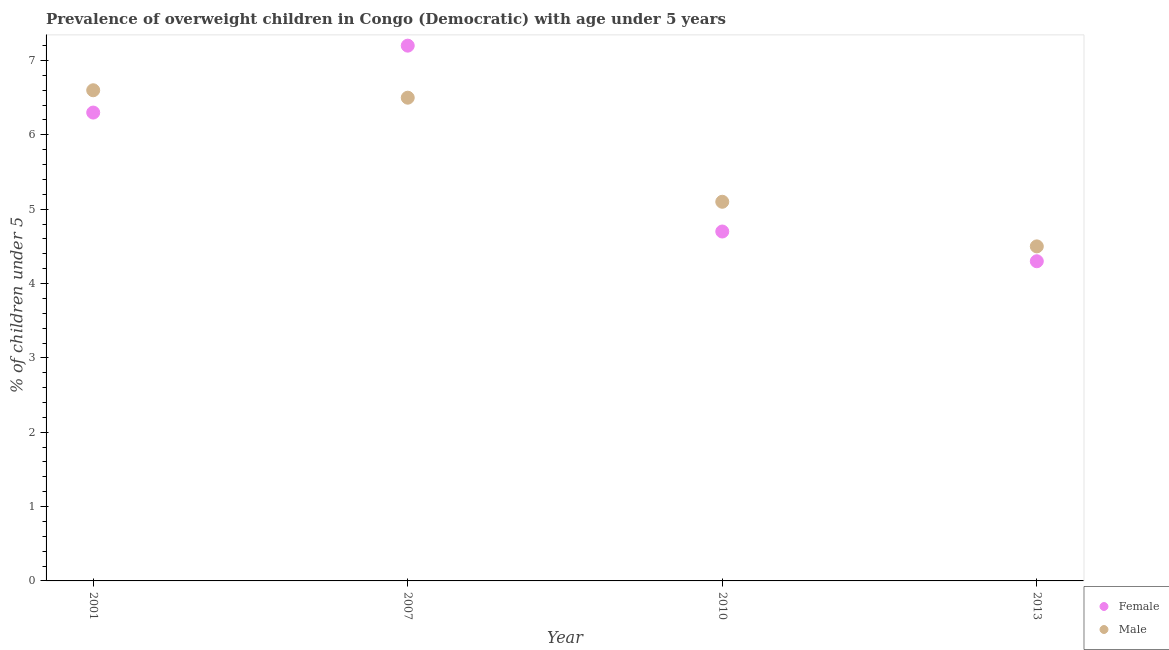How many different coloured dotlines are there?
Offer a terse response. 2. What is the percentage of obese male children in 2010?
Keep it short and to the point. 5.1. Across all years, what is the maximum percentage of obese male children?
Provide a short and direct response. 6.6. Across all years, what is the minimum percentage of obese female children?
Make the answer very short. 4.3. What is the total percentage of obese male children in the graph?
Offer a very short reply. 22.7. What is the difference between the percentage of obese female children in 2007 and that in 2010?
Provide a succinct answer. 2.5. What is the difference between the percentage of obese female children in 2001 and the percentage of obese male children in 2013?
Keep it short and to the point. 1.8. What is the average percentage of obese male children per year?
Provide a short and direct response. 5.67. In the year 2010, what is the difference between the percentage of obese female children and percentage of obese male children?
Ensure brevity in your answer.  -0.4. What is the ratio of the percentage of obese male children in 2001 to that in 2013?
Your response must be concise. 1.47. Is the difference between the percentage of obese female children in 2001 and 2013 greater than the difference between the percentage of obese male children in 2001 and 2013?
Keep it short and to the point. No. What is the difference between the highest and the second highest percentage of obese male children?
Your response must be concise. 0.1. What is the difference between the highest and the lowest percentage of obese female children?
Provide a short and direct response. 2.9. Is the sum of the percentage of obese male children in 2010 and 2013 greater than the maximum percentage of obese female children across all years?
Offer a terse response. Yes. Does the percentage of obese male children monotonically increase over the years?
Your answer should be very brief. No. Is the percentage of obese female children strictly less than the percentage of obese male children over the years?
Keep it short and to the point. No. How many dotlines are there?
Give a very brief answer. 2. How many years are there in the graph?
Give a very brief answer. 4. Are the values on the major ticks of Y-axis written in scientific E-notation?
Provide a succinct answer. No. Does the graph contain any zero values?
Your answer should be very brief. No. Where does the legend appear in the graph?
Offer a very short reply. Bottom right. What is the title of the graph?
Give a very brief answer. Prevalence of overweight children in Congo (Democratic) with age under 5 years. What is the label or title of the Y-axis?
Provide a short and direct response.  % of children under 5. What is the  % of children under 5 of Female in 2001?
Your response must be concise. 6.3. What is the  % of children under 5 in Male in 2001?
Your answer should be compact. 6.6. What is the  % of children under 5 of Female in 2007?
Offer a terse response. 7.2. What is the  % of children under 5 of Male in 2007?
Keep it short and to the point. 6.5. What is the  % of children under 5 in Female in 2010?
Provide a succinct answer. 4.7. What is the  % of children under 5 in Male in 2010?
Ensure brevity in your answer.  5.1. What is the  % of children under 5 of Female in 2013?
Make the answer very short. 4.3. Across all years, what is the maximum  % of children under 5 in Female?
Your response must be concise. 7.2. Across all years, what is the maximum  % of children under 5 in Male?
Your answer should be very brief. 6.6. Across all years, what is the minimum  % of children under 5 of Female?
Your answer should be very brief. 4.3. Across all years, what is the minimum  % of children under 5 of Male?
Provide a succinct answer. 4.5. What is the total  % of children under 5 of Male in the graph?
Provide a short and direct response. 22.7. What is the difference between the  % of children under 5 of Female in 2001 and that in 2007?
Offer a very short reply. -0.9. What is the difference between the  % of children under 5 in Male in 2001 and that in 2007?
Offer a terse response. 0.1. What is the difference between the  % of children under 5 of Male in 2001 and that in 2010?
Keep it short and to the point. 1.5. What is the difference between the  % of children under 5 in Male in 2001 and that in 2013?
Provide a succinct answer. 2.1. What is the difference between the  % of children under 5 of Female in 2007 and that in 2013?
Your answer should be very brief. 2.9. What is the difference between the  % of children under 5 of Female in 2010 and that in 2013?
Offer a very short reply. 0.4. What is the difference between the  % of children under 5 of Male in 2010 and that in 2013?
Provide a succinct answer. 0.6. What is the difference between the  % of children under 5 in Female in 2001 and the  % of children under 5 in Male in 2013?
Provide a short and direct response. 1.8. What is the difference between the  % of children under 5 of Female in 2007 and the  % of children under 5 of Male in 2010?
Your response must be concise. 2.1. What is the difference between the  % of children under 5 of Female in 2007 and the  % of children under 5 of Male in 2013?
Provide a short and direct response. 2.7. What is the difference between the  % of children under 5 of Female in 2010 and the  % of children under 5 of Male in 2013?
Your response must be concise. 0.2. What is the average  % of children under 5 in Female per year?
Your answer should be compact. 5.62. What is the average  % of children under 5 in Male per year?
Offer a very short reply. 5.67. In the year 2001, what is the difference between the  % of children under 5 in Female and  % of children under 5 in Male?
Keep it short and to the point. -0.3. What is the ratio of the  % of children under 5 in Female in 2001 to that in 2007?
Your answer should be very brief. 0.88. What is the ratio of the  % of children under 5 of Male in 2001 to that in 2007?
Ensure brevity in your answer.  1.02. What is the ratio of the  % of children under 5 in Female in 2001 to that in 2010?
Offer a terse response. 1.34. What is the ratio of the  % of children under 5 of Male in 2001 to that in 2010?
Your answer should be compact. 1.29. What is the ratio of the  % of children under 5 in Female in 2001 to that in 2013?
Make the answer very short. 1.47. What is the ratio of the  % of children under 5 of Male in 2001 to that in 2013?
Your answer should be compact. 1.47. What is the ratio of the  % of children under 5 in Female in 2007 to that in 2010?
Provide a short and direct response. 1.53. What is the ratio of the  % of children under 5 of Male in 2007 to that in 2010?
Your answer should be compact. 1.27. What is the ratio of the  % of children under 5 of Female in 2007 to that in 2013?
Offer a very short reply. 1.67. What is the ratio of the  % of children under 5 in Male in 2007 to that in 2013?
Provide a succinct answer. 1.44. What is the ratio of the  % of children under 5 of Female in 2010 to that in 2013?
Your answer should be very brief. 1.09. What is the ratio of the  % of children under 5 of Male in 2010 to that in 2013?
Your answer should be very brief. 1.13. What is the difference between the highest and the second highest  % of children under 5 of Female?
Make the answer very short. 0.9. 